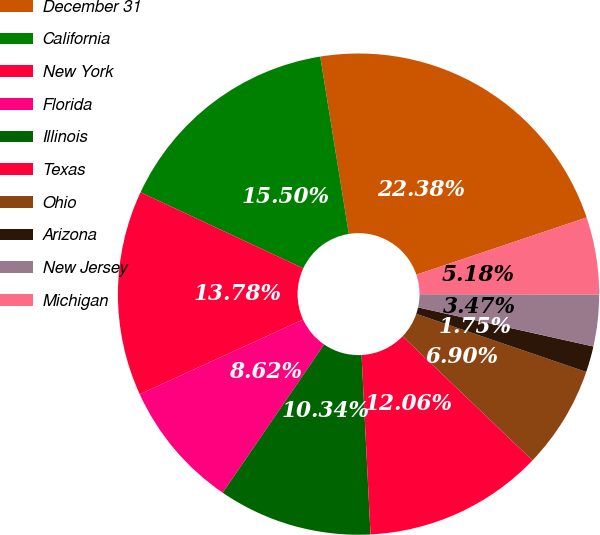Convert chart to OTSL. <chart><loc_0><loc_0><loc_500><loc_500><pie_chart><fcel>December 31<fcel>California<fcel>New York<fcel>Florida<fcel>Illinois<fcel>Texas<fcel>Ohio<fcel>Arizona<fcel>New Jersey<fcel>Michigan<nl><fcel>22.38%<fcel>15.5%<fcel>13.78%<fcel>8.62%<fcel>10.34%<fcel>12.06%<fcel>6.9%<fcel>1.75%<fcel>3.47%<fcel>5.18%<nl></chart> 